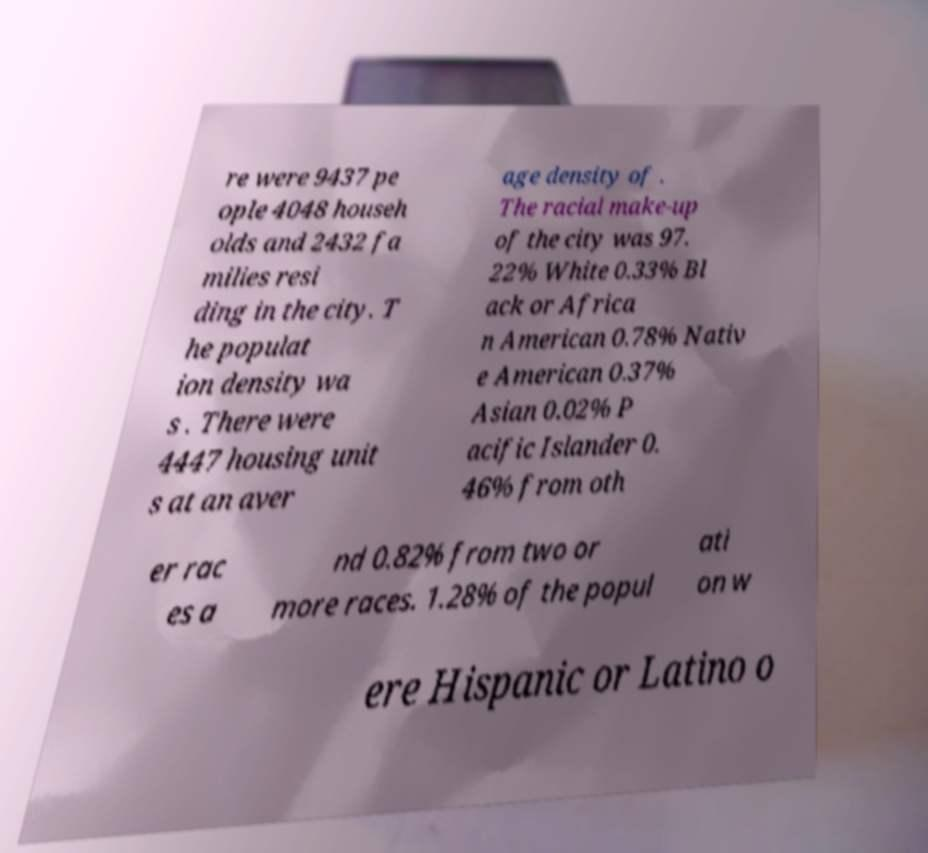Could you extract and type out the text from this image? re were 9437 pe ople 4048 househ olds and 2432 fa milies resi ding in the city. T he populat ion density wa s . There were 4447 housing unit s at an aver age density of . The racial make-up of the city was 97. 22% White 0.33% Bl ack or Africa n American 0.78% Nativ e American 0.37% Asian 0.02% P acific Islander 0. 46% from oth er rac es a nd 0.82% from two or more races. 1.28% of the popul ati on w ere Hispanic or Latino o 